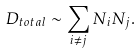Convert formula to latex. <formula><loc_0><loc_0><loc_500><loc_500>D _ { t o t a l } \sim \sum _ { i \neq j } N _ { i } N _ { j } .</formula> 